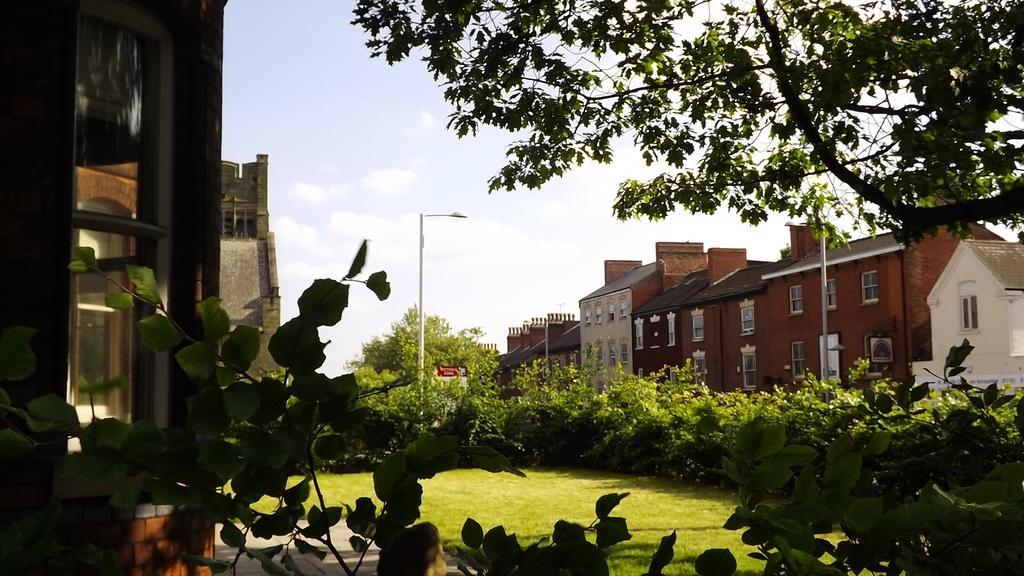Describe this image in one or two sentences. In this picture we can see few houses, poles, trees and grass. 